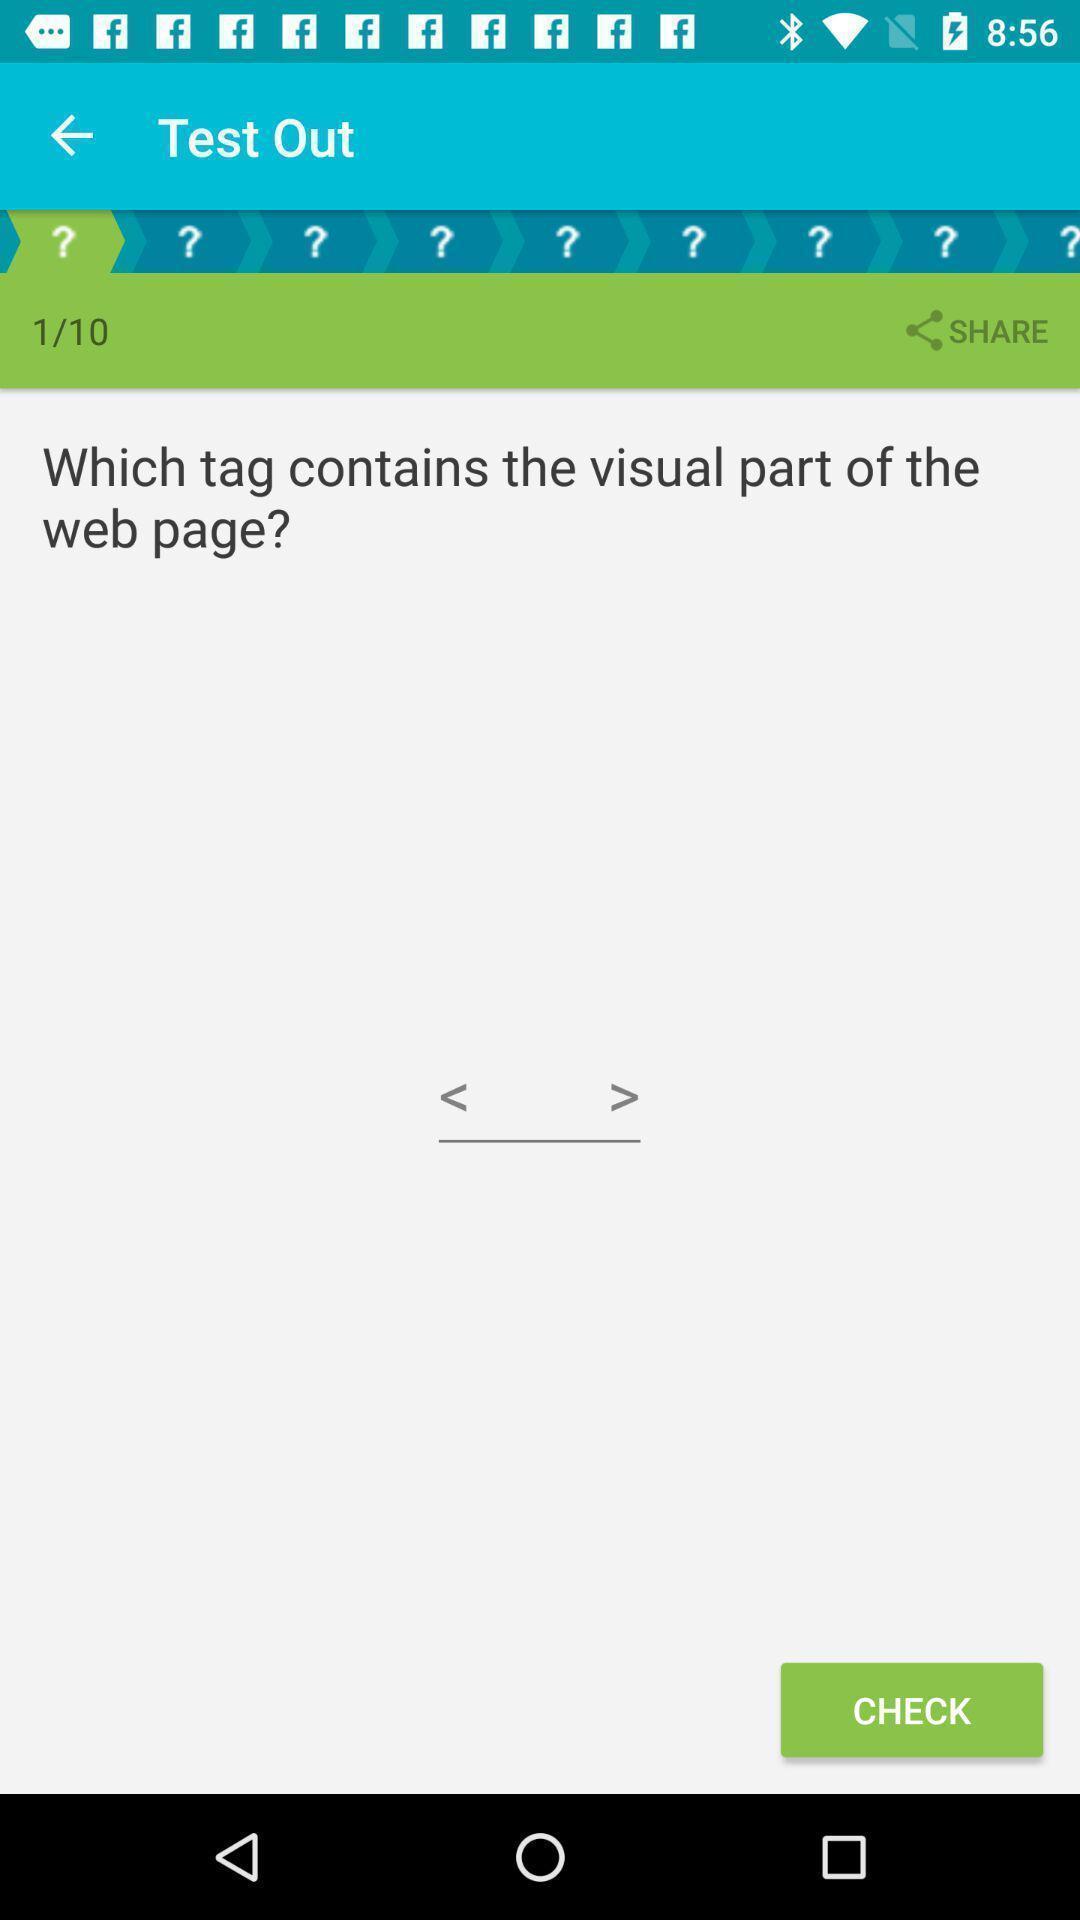Summarize the main components in this picture. Question is displaying in a learning app. 